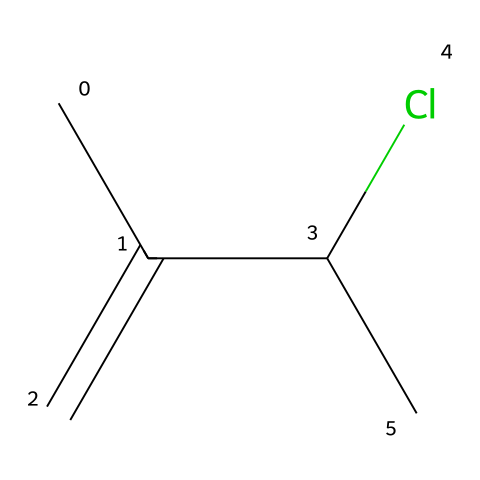What is the total number of carbon atoms in the chemical? The SMILES representation shows "CC(=C)C(Cl)C", indicating there are five "C" symbols in the sequence, which represents five carbon atoms in total.
Answer: five How many chlorine atoms are present in the chemical? In the SMILES notation "CC(=C)C(Cl)C", there’s one "Cl" symbol which indicates the presence of one chlorine atom.
Answer: one What type of bonding is present in the neoprene structure? The presence of the "=C" in the SMILES indicates a double bond between the carbon atoms, while the rest of the connections represent single bonds.
Answer: double and single bonds What does the "CC(=C)" segment indicate about the structure? The "CC(=C)" segment shows a carbon-carbon double bond (due to "=C") indicating an alkene structure, which is essential for polymer formation.
Answer: alkene structure What role does chlorine play in the chemical's properties? Chlorine, indicated by "Cl", can affect the polymer's properties such as flexibility, resistance, and overall durability, which contributes to neoprene being used in wetsuits.
Answer: enhances durability How many distinct types of atoms are in this molecule? The molecule contains carbon (C) and chlorine (Cl) atoms; thus, it has two distinct types of atoms.
Answer: two What classification does neoprene fall under based on its chemical structure? Neoprene is a synthetic polymer, characterized as a rubber due to its long chains of repeating structural units formed through polymerization, which reflects its utility in wetsuits.
Answer: synthetic polymer 